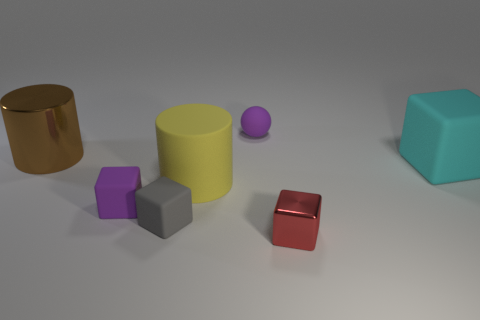Is there a small red object that has the same shape as the big metal object?
Ensure brevity in your answer.  No. What shape is the red metal object that is the same size as the rubber ball?
Provide a short and direct response. Cube. There is a matte thing on the right side of the small rubber object behind the rubber block behind the small purple rubber cube; what shape is it?
Your response must be concise. Cube. Does the cyan thing have the same shape as the purple thing to the right of the purple block?
Offer a terse response. No. What number of large objects are gray rubber blocks or purple matte blocks?
Keep it short and to the point. 0. Are there any brown metallic objects of the same size as the red cube?
Provide a succinct answer. No. The cylinder that is in front of the object that is on the left side of the purple matte thing on the left side of the big yellow matte cylinder is what color?
Provide a succinct answer. Yellow. Do the tiny red block and the cylinder behind the large yellow thing have the same material?
Provide a succinct answer. Yes. What size is the red object that is the same shape as the large cyan matte object?
Offer a terse response. Small. Are there the same number of objects that are behind the tiny gray cube and tiny rubber balls that are in front of the matte sphere?
Give a very brief answer. No. 